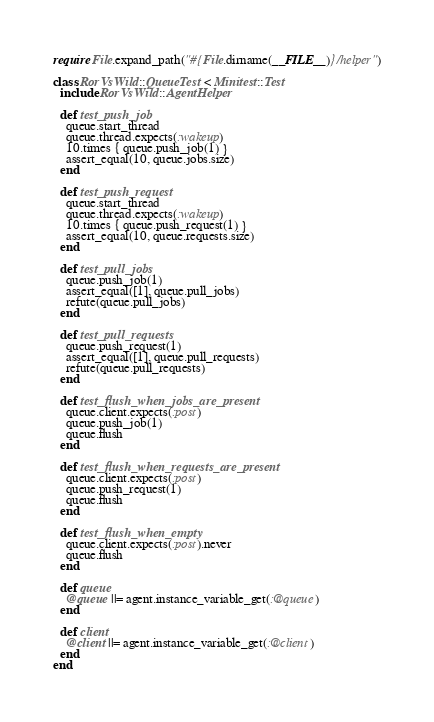<code> <loc_0><loc_0><loc_500><loc_500><_Ruby_>require File.expand_path("#{File.dirname(__FILE__)}/helper")

class RorVsWild::QueueTest < Minitest::Test
  include RorVsWild::AgentHelper

  def test_push_job
    queue.start_thread
    queue.thread.expects(:wakeup)
    10.times { queue.push_job(1) }
    assert_equal(10, queue.jobs.size)
  end

  def test_push_request
    queue.start_thread
    queue.thread.expects(:wakeup)
    10.times { queue.push_request(1) }
    assert_equal(10, queue.requests.size)
  end

  def test_pull_jobs
    queue.push_job(1)
    assert_equal([1], queue.pull_jobs)
    refute(queue.pull_jobs)
  end

  def test_pull_requests
    queue.push_request(1)
    assert_equal([1], queue.pull_requests)
    refute(queue.pull_requests)
  end

  def test_flush_when_jobs_are_present
    queue.client.expects(:post)
    queue.push_job(1)
    queue.flush
  end

  def test_flush_when_requests_are_present
    queue.client.expects(:post)
    queue.push_request(1)
    queue.flush
  end

  def test_flush_when_empty
    queue.client.expects(:post).never
    queue.flush
  end

  def queue
    @queue ||= agent.instance_variable_get(:@queue)
  end

  def client
    @client ||= agent.instance_variable_get(:@client)
  end
end
</code> 